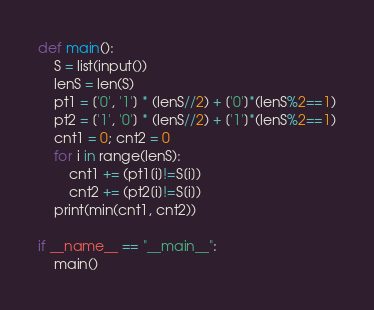Convert code to text. <code><loc_0><loc_0><loc_500><loc_500><_Python_>def main():
    S = list(input())
    lenS = len(S)
    pt1 = ['0', '1'] * (lenS//2) + ['0']*(lenS%2==1)
    pt2 = ['1', '0'] * (lenS//2) + ['1']*(lenS%2==1)
    cnt1 = 0; cnt2 = 0
    for i in range(lenS):
        cnt1 += (pt1[i]!=S[i])
        cnt2 += (pt2[i]!=S[i])
    print(min(cnt1, cnt2))

if __name__ == "__main__":
    main()
</code> 